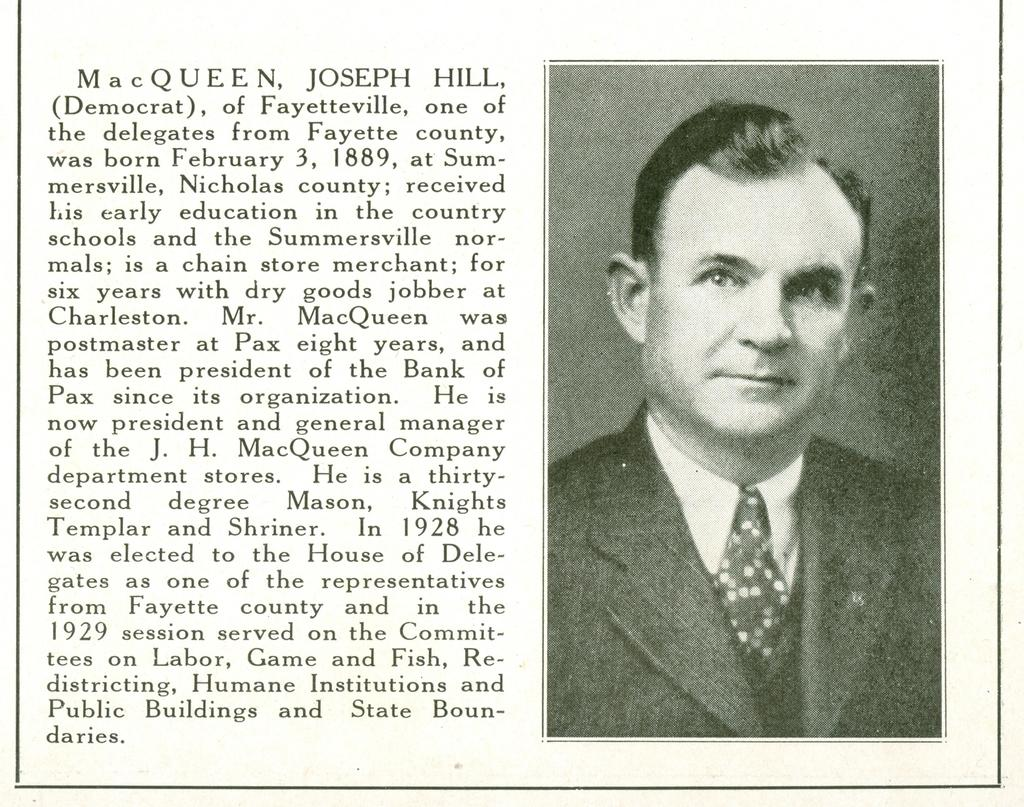What is depicted on the right side of the image? There is a picture of a man on the right side of the image. What can be found on the left side of the image? There is text or writing on the left side of the image. Is there a ghost visible in the image? No, there is no ghost present in the image. What type of key is being used in the attempt to unlock the door in the image? There is no door or key present in the image; it only features a picture of a man and text or writing. 